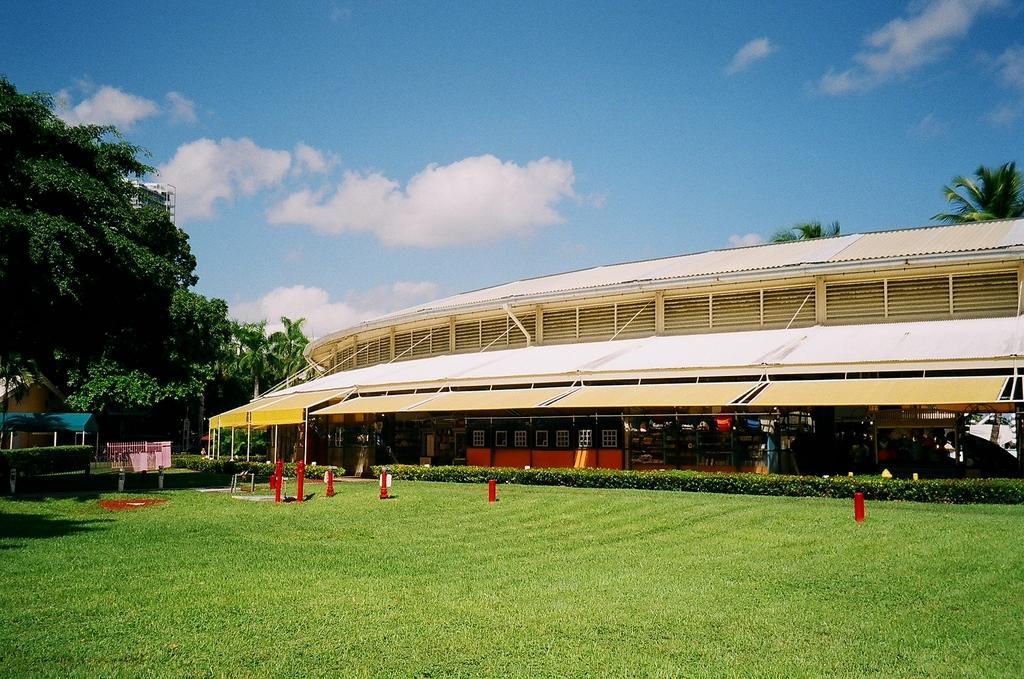Could you give a brief overview of what you see in this image? In the picture we can see a grass surface with some plants far from it and near it, we can see a building with shed and some things are placed under it and on the left hand side we can see some trees and in the background we can see a sky with clouds. 